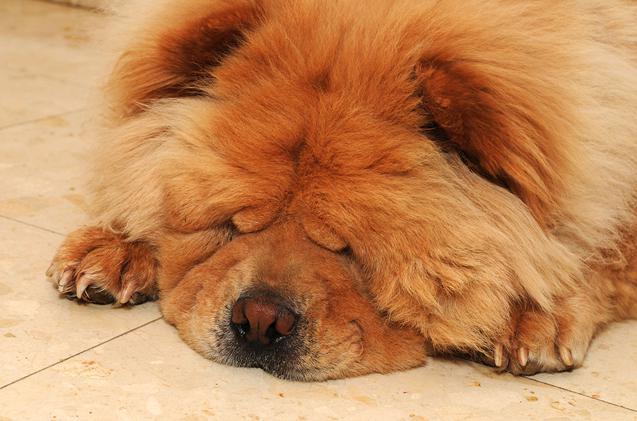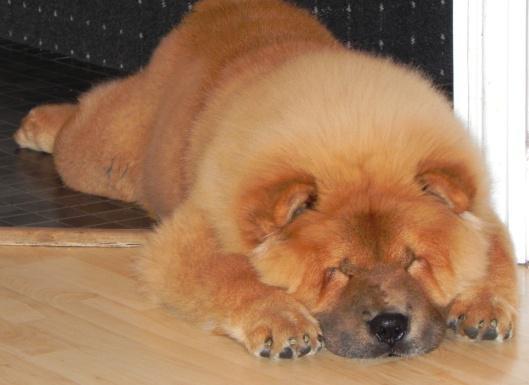The first image is the image on the left, the second image is the image on the right. Given the left and right images, does the statement "An image shows a chow dog sleeping up off the ground, on some type of seat." hold true? Answer yes or no. No. The first image is the image on the left, the second image is the image on the right. Assess this claim about the two images: "The dog in the image on the left is sleeping on the tiled surface.". Correct or not? Answer yes or no. Yes. 